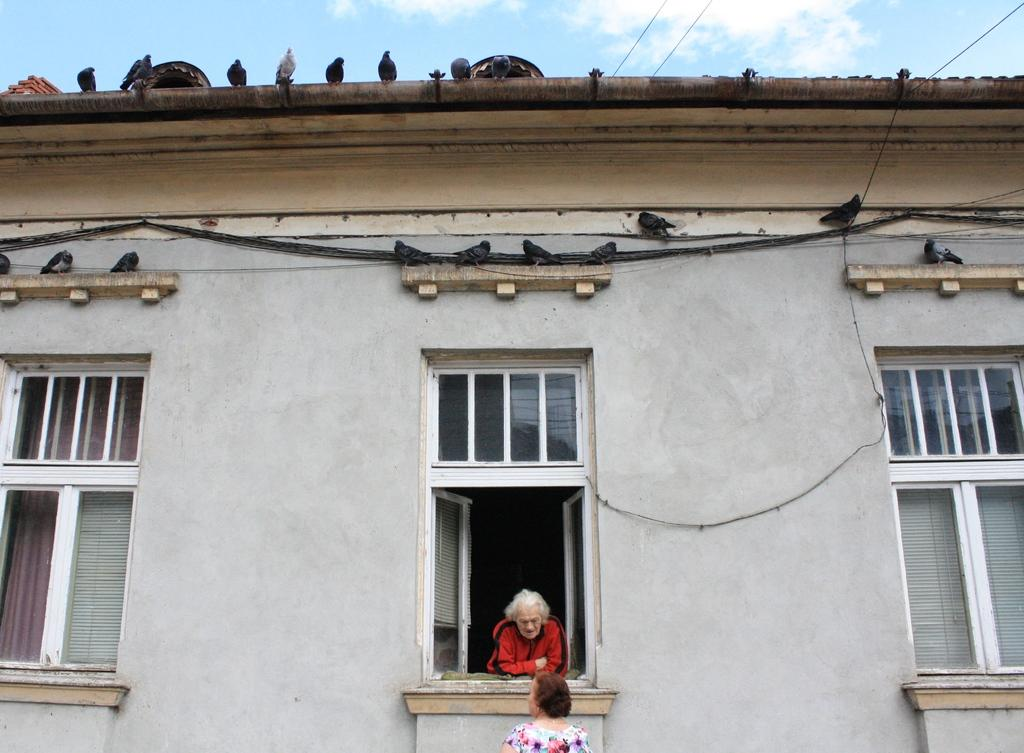What type of structure is in the picture? There is a building in the picture. What features can be seen on the building? The building has windows and curtains. What else is visible in the picture? There are wires and pigeons visible in the picture. How many women are in the picture? There are two women in the picture. What is visible in the background of the picture? The sky is visible in the background of the picture. What can be seen in the sky? There are clouds in the sky. What type of bomb is being diffused by the women in the picture? There is no bomb present in the picture; it features a building with windows, curtains, wires, pigeons, and two women. What is the women's fear of in the picture? There is no indication of fear in the picture; it simply shows a building, wires, pigeons, and two women. 